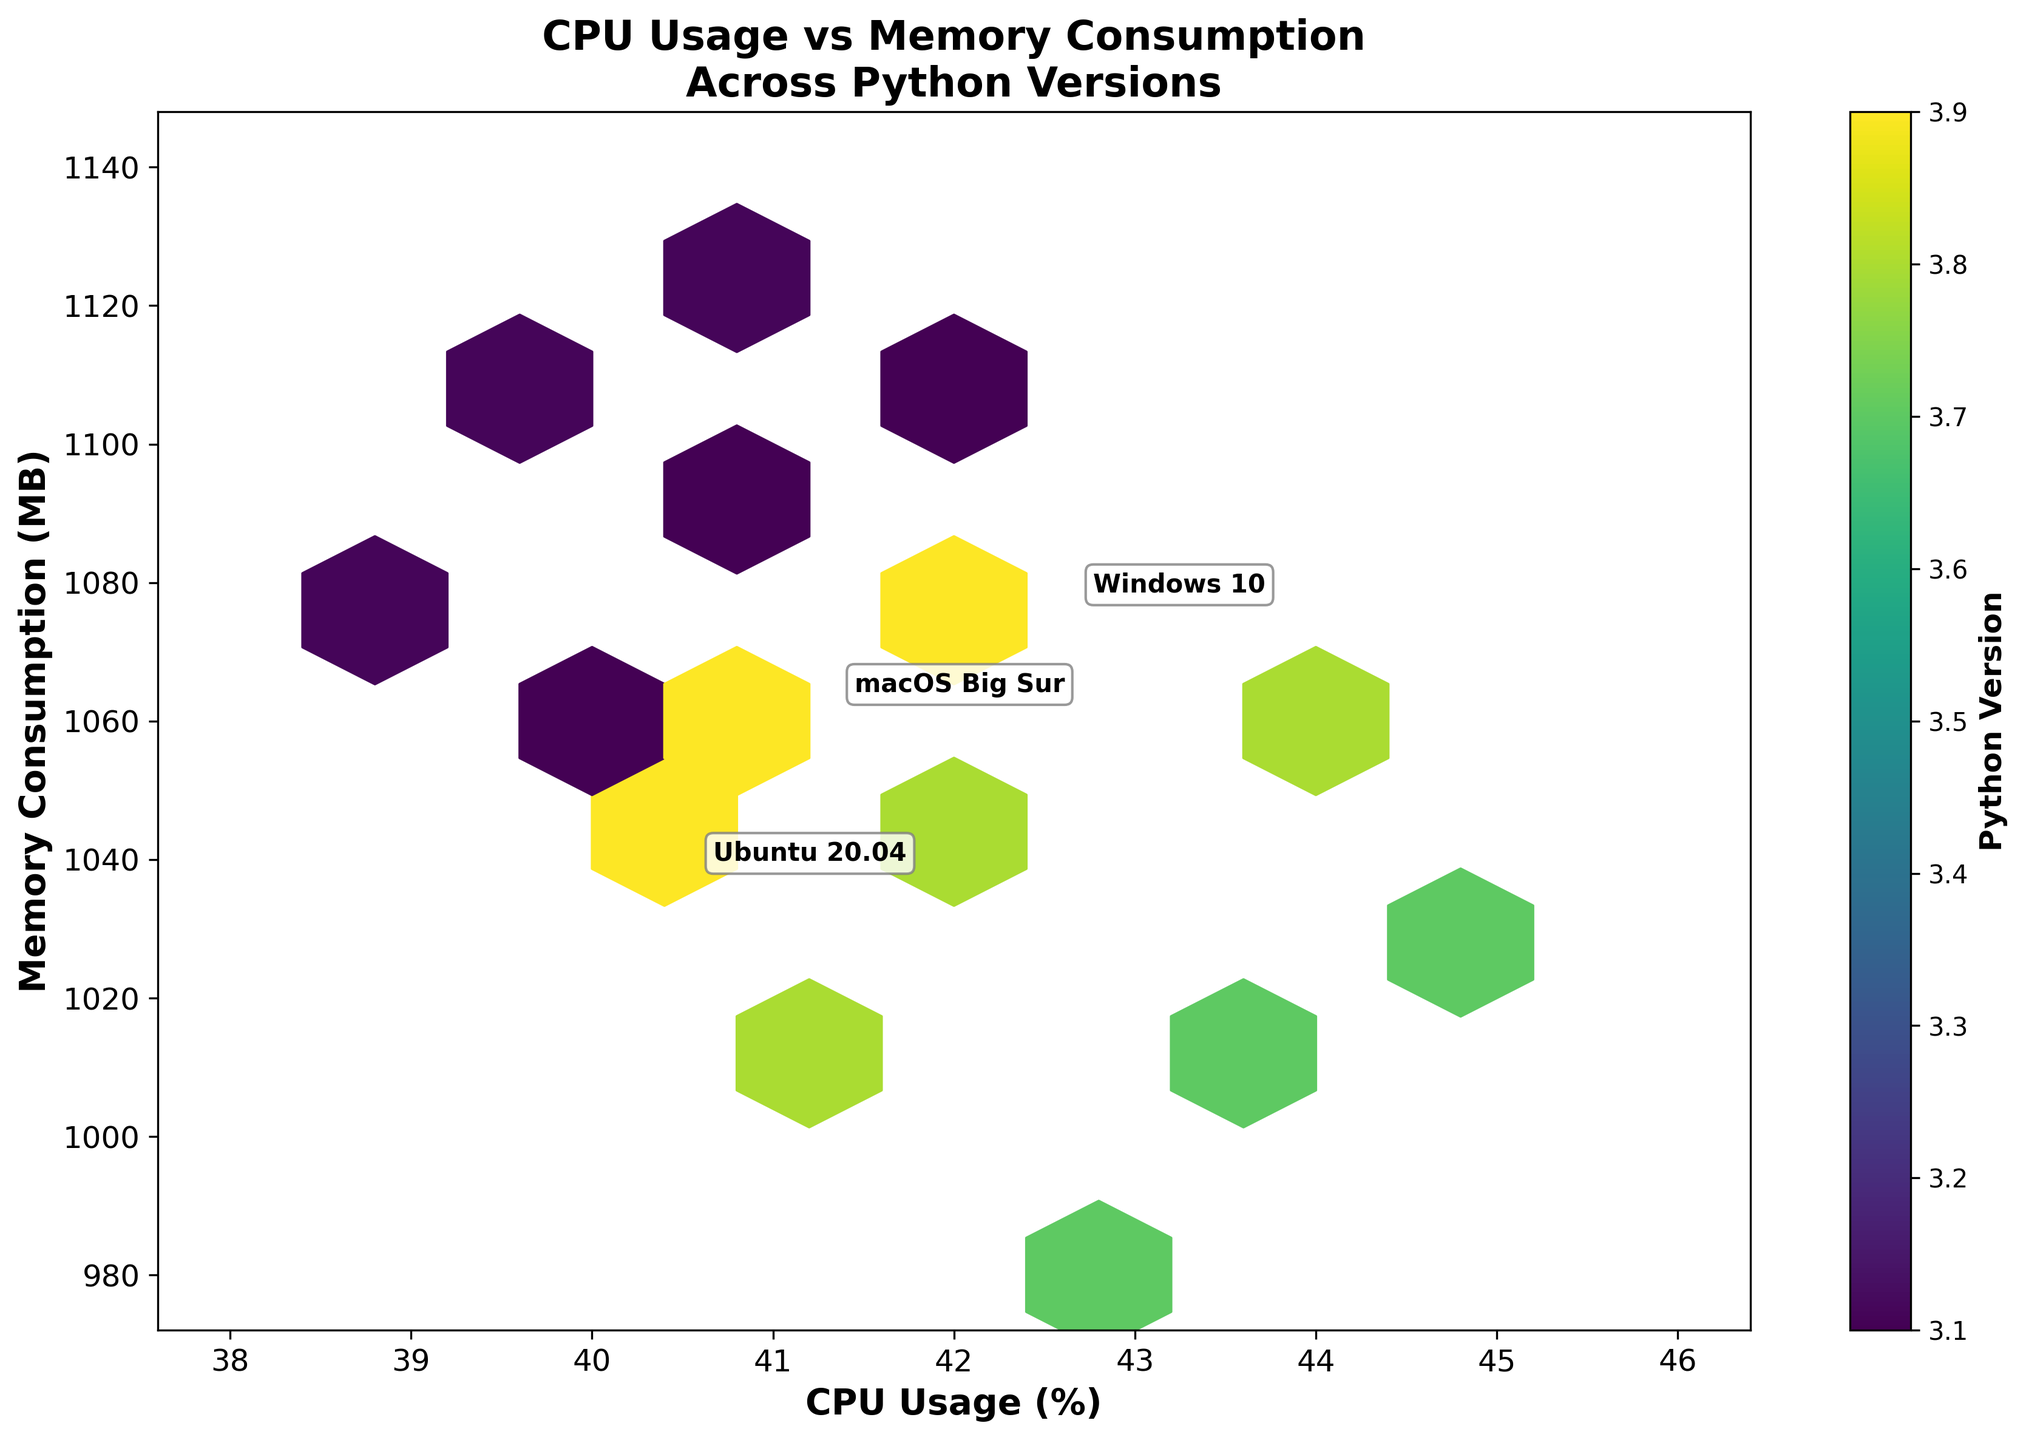What is the title of the hexbin plot? The title is typically positioned at the top center of the plot, mentioning what the plot is about. In this case, it reads "CPU Usage vs Memory Consumption\nAcross Python Versions".
Answer: CPU Usage vs Memory Consumption Across Python Versions What do the x-axis and y-axis represent? The x-axis and y-axis labels tell us what each axis stands for. The x-axis represents "CPU Usage (%)" and the y-axis represents "Memory Consumption (MB)".
Answer: CPU Usage (%), Memory Consumption (MB) What is the color scale representing? The color scale on the right side of the plot, usually accompanied by a color bar, indicates that it represents the different "Python Versions".
Answer: Python Versions Approximately, how many data points are represented in the hexbin plot? The number of data points can be inferred by referring to the extent and grid size specified in the plot generation. Since the data has 15 rows and the grid size is 10, it suggests a moderately clustered distribution of data points.
Answer: 15 Which operating system appears to have the highest average CPU usage? By looking at the annotations for each operating system and locating the one with the highest CPU usage value on the x-axis, we observe that Windows 10 has its annotations closer to the higher end.
Answer: Windows 10 By observing the plot, which Python version appears to have the highest average memory consumption? By looking at the color gradient on the hexbin plot, darker shades (representing higher Python versions) clustered around the highest memory consumption values on the y-axis suggest that Python 3.11 has the highest average memory consumption.
Answer: Python 3.11 How does memory consumption of Ubuntu 20.04 compare to that of Windows 10 on average? By comparing the annotations for both operating systems, we see that Windows 10 has higher overall memory consumption values on the y-axis, indicating that it is generally higher than Ubuntu 20.04.
Answer: Higher What trend can you observe about CPU usage vs Python versions? The hexbin plot color gradient shows a trend where newer Python versions (darker colors) tend to cluster towards lower CPU usage values on the x-axis. This indicates that CPU usage generally decreases as Python versions increase.
Answer: CPU usage decreases with newer Python versions Can you describe the relationship between CPU usage and memory consumption? From the hexbin plot, an overall trend indicating that higher CPU usage values tend to correspond with higher memory consumption values can be observed, although there are scattered points that deviate.
Answer: Positive correlation 